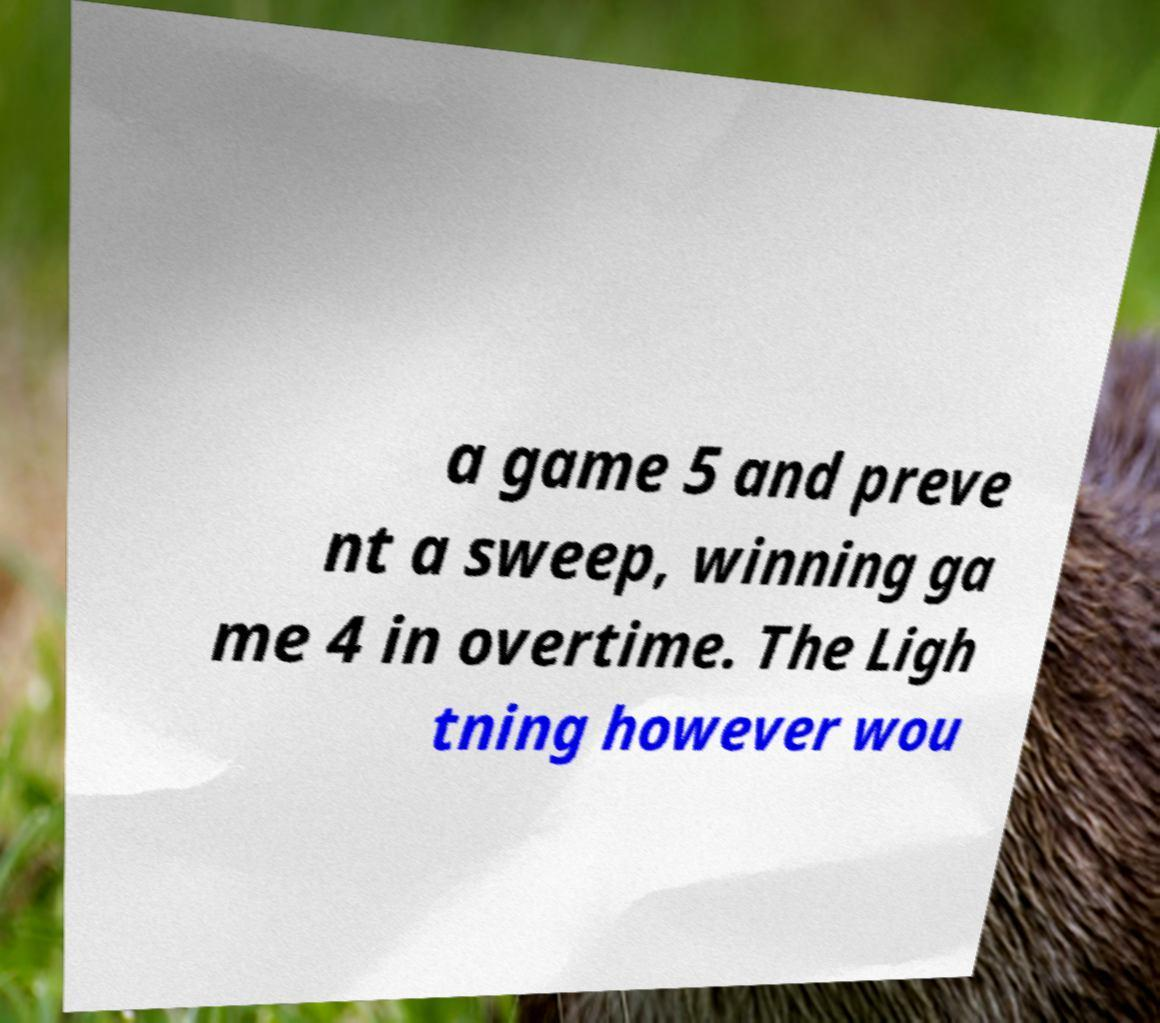Can you read and provide the text displayed in the image?This photo seems to have some interesting text. Can you extract and type it out for me? a game 5 and preve nt a sweep, winning ga me 4 in overtime. The Ligh tning however wou 